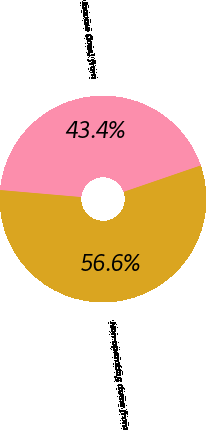Convert chart to OTSL. <chart><loc_0><loc_0><loc_500><loc_500><pie_chart><fcel>Income (loss) from<fcel>Non-operating items from<nl><fcel>43.36%<fcel>56.64%<nl></chart> 